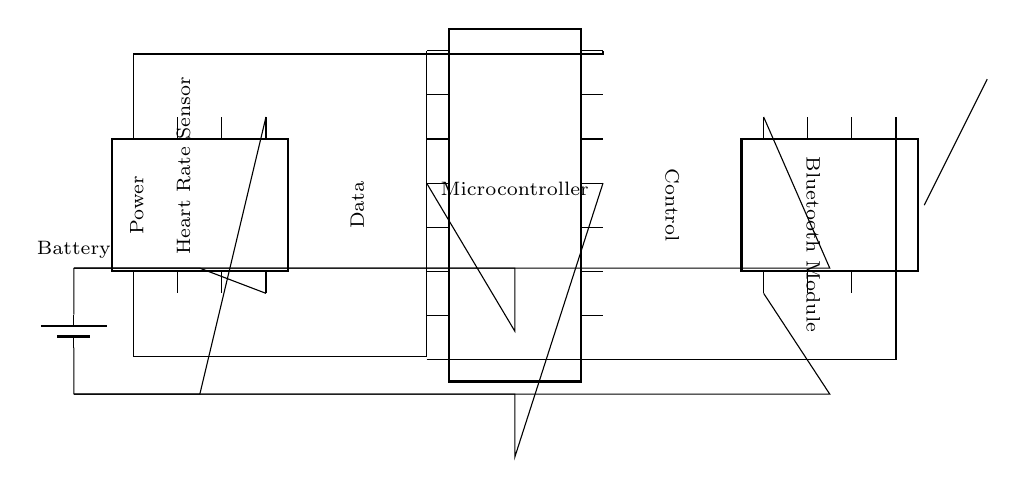What is the main function of the Bluetooth module? The Bluetooth module is responsible for wireless communication. It connects the microcontroller to other devices, allowing data transmission.
Answer: wireless communication How many pins does the microcontroller have? The microcontroller is depicted with 16 pins shown in the diagram. This tells us how many connection points are available for the components.
Answer: 16 What type of power source is used in this circuit? A battery is used as the power source, as indicated by the labeled battery symbol in the circuit diagram.
Answer: battery What is the purpose of the heart rate sensor in this circuit? The heart rate sensor collects the user's heart rate data, which is essential for fitness tracking. This data is then processed by the microcontroller.
Answer: fitness tracking Which component is connected to the antenna? The Bluetooth module is connected to the antenna, allowing it to transmit and receive Bluetooth signals necessary for communication.
Answer: Bluetooth module How is data routed from the heart rate sensor to the microcontroller? The data is routed using connections from pin 1 and pin 8 of the heart rate sensor to pin 1 and pin 16 of the microcontroller. This indicates a direct data link between the two components.
Answer: through connections 